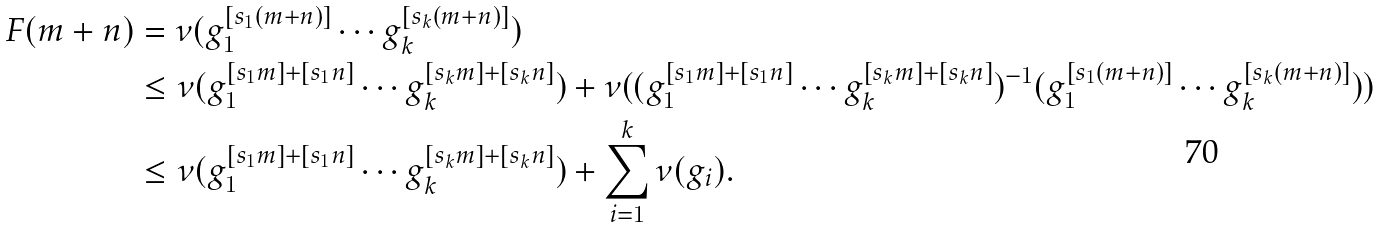<formula> <loc_0><loc_0><loc_500><loc_500>F ( m + n ) & = \nu ( g _ { 1 } ^ { [ s _ { 1 } ( m + n ) ] } \cdots g _ { k } ^ { [ s _ { k } ( m + n ) ] } ) \\ & \leq \nu ( g _ { 1 } ^ { [ s _ { 1 } m ] + [ s _ { 1 } n ] } \cdots g _ { k } ^ { [ s _ { k } m ] + [ s _ { k } n ] } ) + \nu ( ( g _ { 1 } ^ { [ s _ { 1 } m ] + [ s _ { 1 } n ] } \cdots g _ { k } ^ { [ s _ { k } m ] + [ s _ { k } n ] } ) ^ { - 1 } ( g _ { 1 } ^ { [ s _ { 1 } ( m + n ) ] } \cdots g _ { k } ^ { [ s _ { k } ( m + n ) ] } ) ) \\ & \leq \nu ( g _ { 1 } ^ { [ s _ { 1 } m ] + [ s _ { 1 } n ] } \cdots g _ { k } ^ { [ s _ { k } m ] + [ s _ { k } n ] } ) + \sum _ { i = 1 } ^ { k } \nu ( g _ { i } ) . \\</formula> 